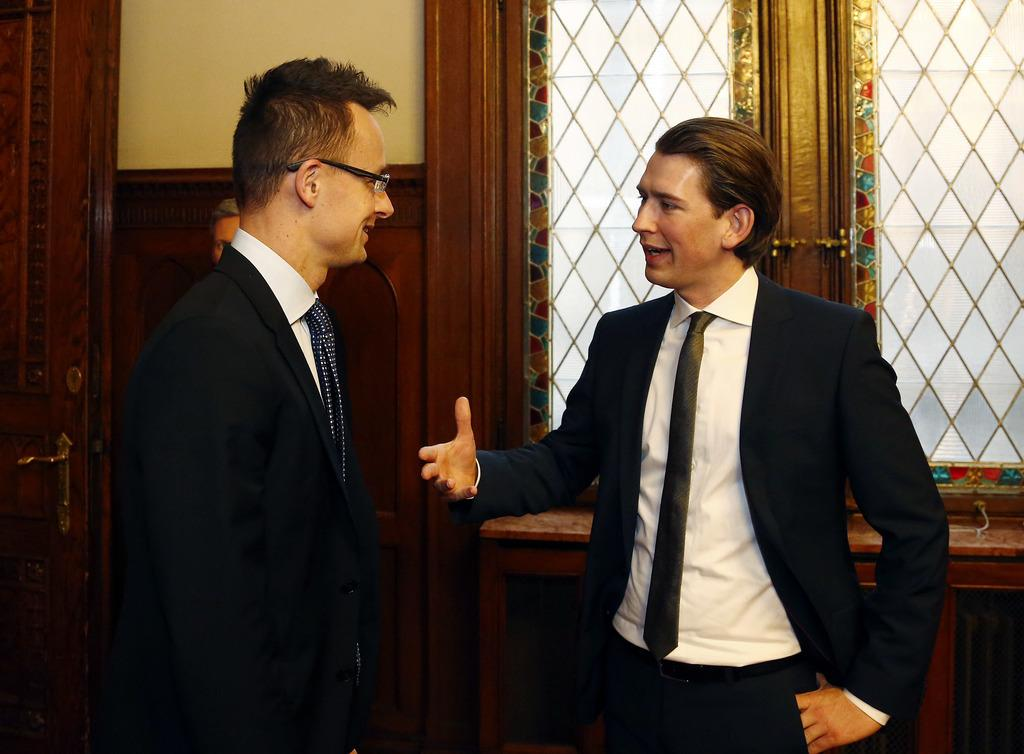How many people are present in the image? There are three persons in the image. What is the background of the image? There is a wall in the image. Are there any openings in the wall? Yes, there are windows and a door in the image. What type of vase can be seen in the image? There is no vase present in the image. How does the sand appear in the image? There is no sand present in the image. Is there a rainstorm happening in the image? There is no indication of a rainstorm in the image. 